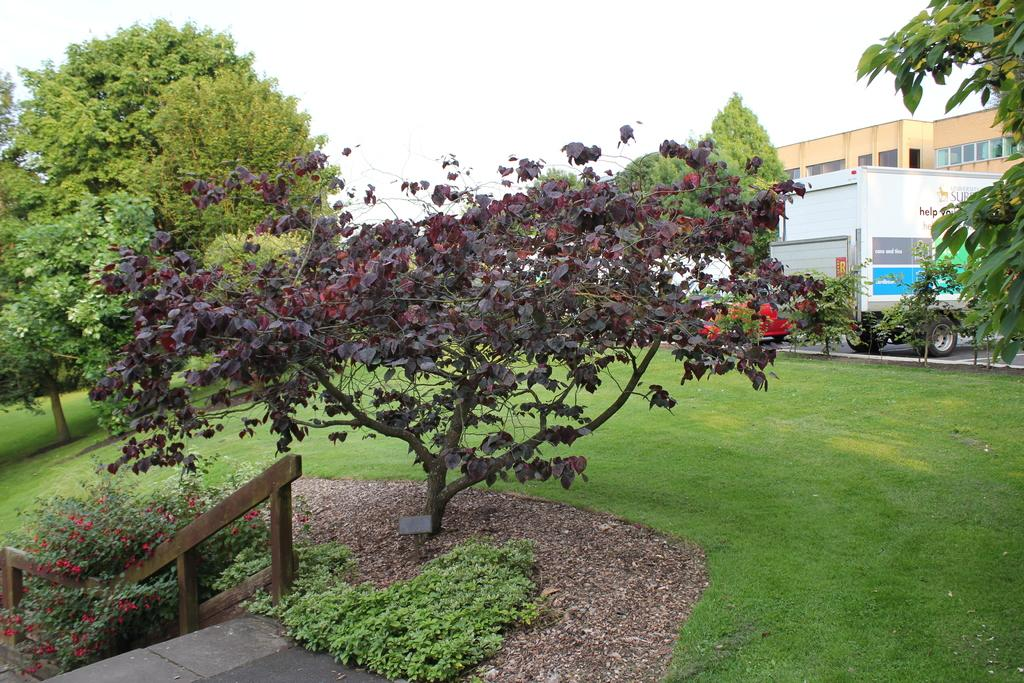What type of vegetation can be seen on the grassland in the image? There are trees on the grassland in the image. What structure is located on the right side in the background of the image? There is a building on the right side in the background of the image. What is in front of the building on the road in the image? There is a vehicle in front of the building on the road in the image. What part of the natural environment is visible above the building in the image? The sky is visible above the building in the image. What type of basin is visible in the image? There is no basin present in the image. What is the author's prose style in the image? The image is not a piece of written prose, so it does not have an author or a prose style. 